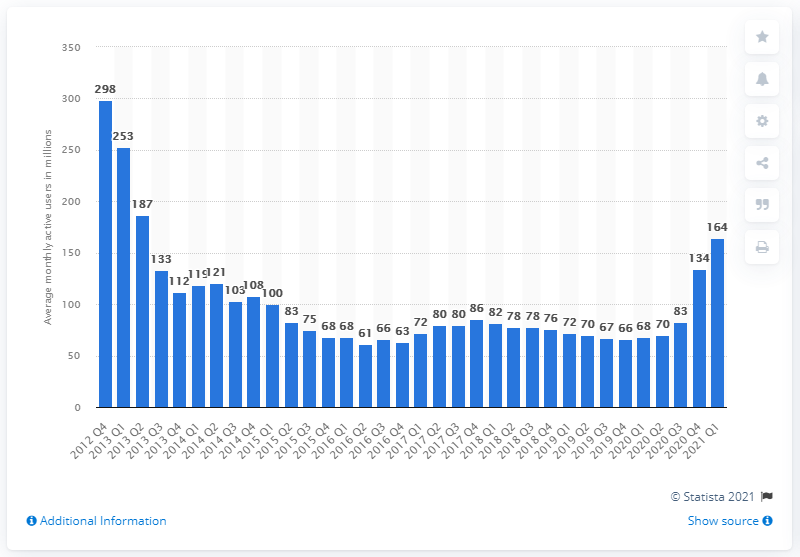List a handful of essential elements in this visual. Zynga reported 164 monthly active users in the first quarter of 2021. 